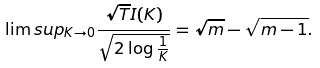Convert formula to latex. <formula><loc_0><loc_0><loc_500><loc_500>\lim s u p _ { K \rightarrow 0 } \frac { \sqrt { T } I ( K ) } { \sqrt { 2 \log \frac { 1 } { K } } } = \sqrt { m } - \sqrt { m - 1 } .</formula> 